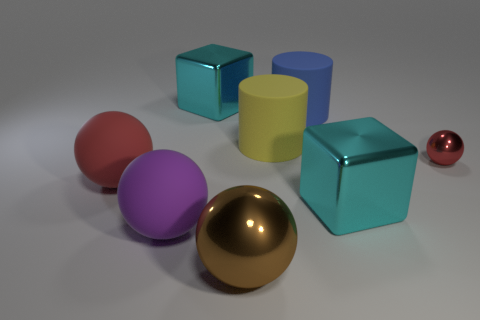Subtract all blue spheres. Subtract all brown cylinders. How many spheres are left? 4 Add 1 large green metal objects. How many objects exist? 9 Subtract all cubes. How many objects are left? 6 Subtract 0 cyan cylinders. How many objects are left? 8 Subtract all purple metal balls. Subtract all big purple spheres. How many objects are left? 7 Add 4 red metal things. How many red metal things are left? 5 Add 6 red shiny things. How many red shiny things exist? 7 